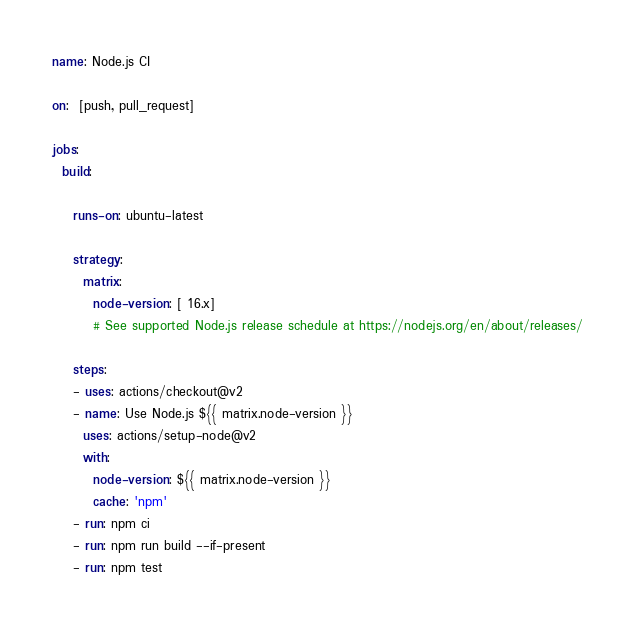Convert code to text. <code><loc_0><loc_0><loc_500><loc_500><_YAML_>
name: Node.js CI

on:  [push, pull_request]
  
jobs:
  build:

    runs-on: ubuntu-latest

    strategy:
      matrix:
        node-version: [ 16.x]
        # See supported Node.js release schedule at https://nodejs.org/en/about/releases/

    steps:
    - uses: actions/checkout@v2
    - name: Use Node.js ${{ matrix.node-version }}
      uses: actions/setup-node@v2
      with:
        node-version: ${{ matrix.node-version }}
        cache: 'npm'
    - run: npm ci
    - run: npm run build --if-present
    - run: npm test
</code> 